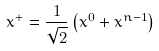Convert formula to latex. <formula><loc_0><loc_0><loc_500><loc_500>x ^ { + } = \frac { 1 } { \sqrt { 2 } } \left ( x ^ { 0 } + x ^ { n - 1 } \right )</formula> 